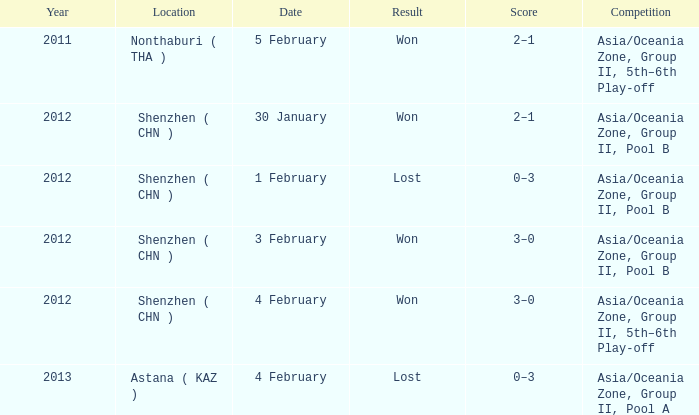What is the sum of the year for 5 february? 2011.0. 